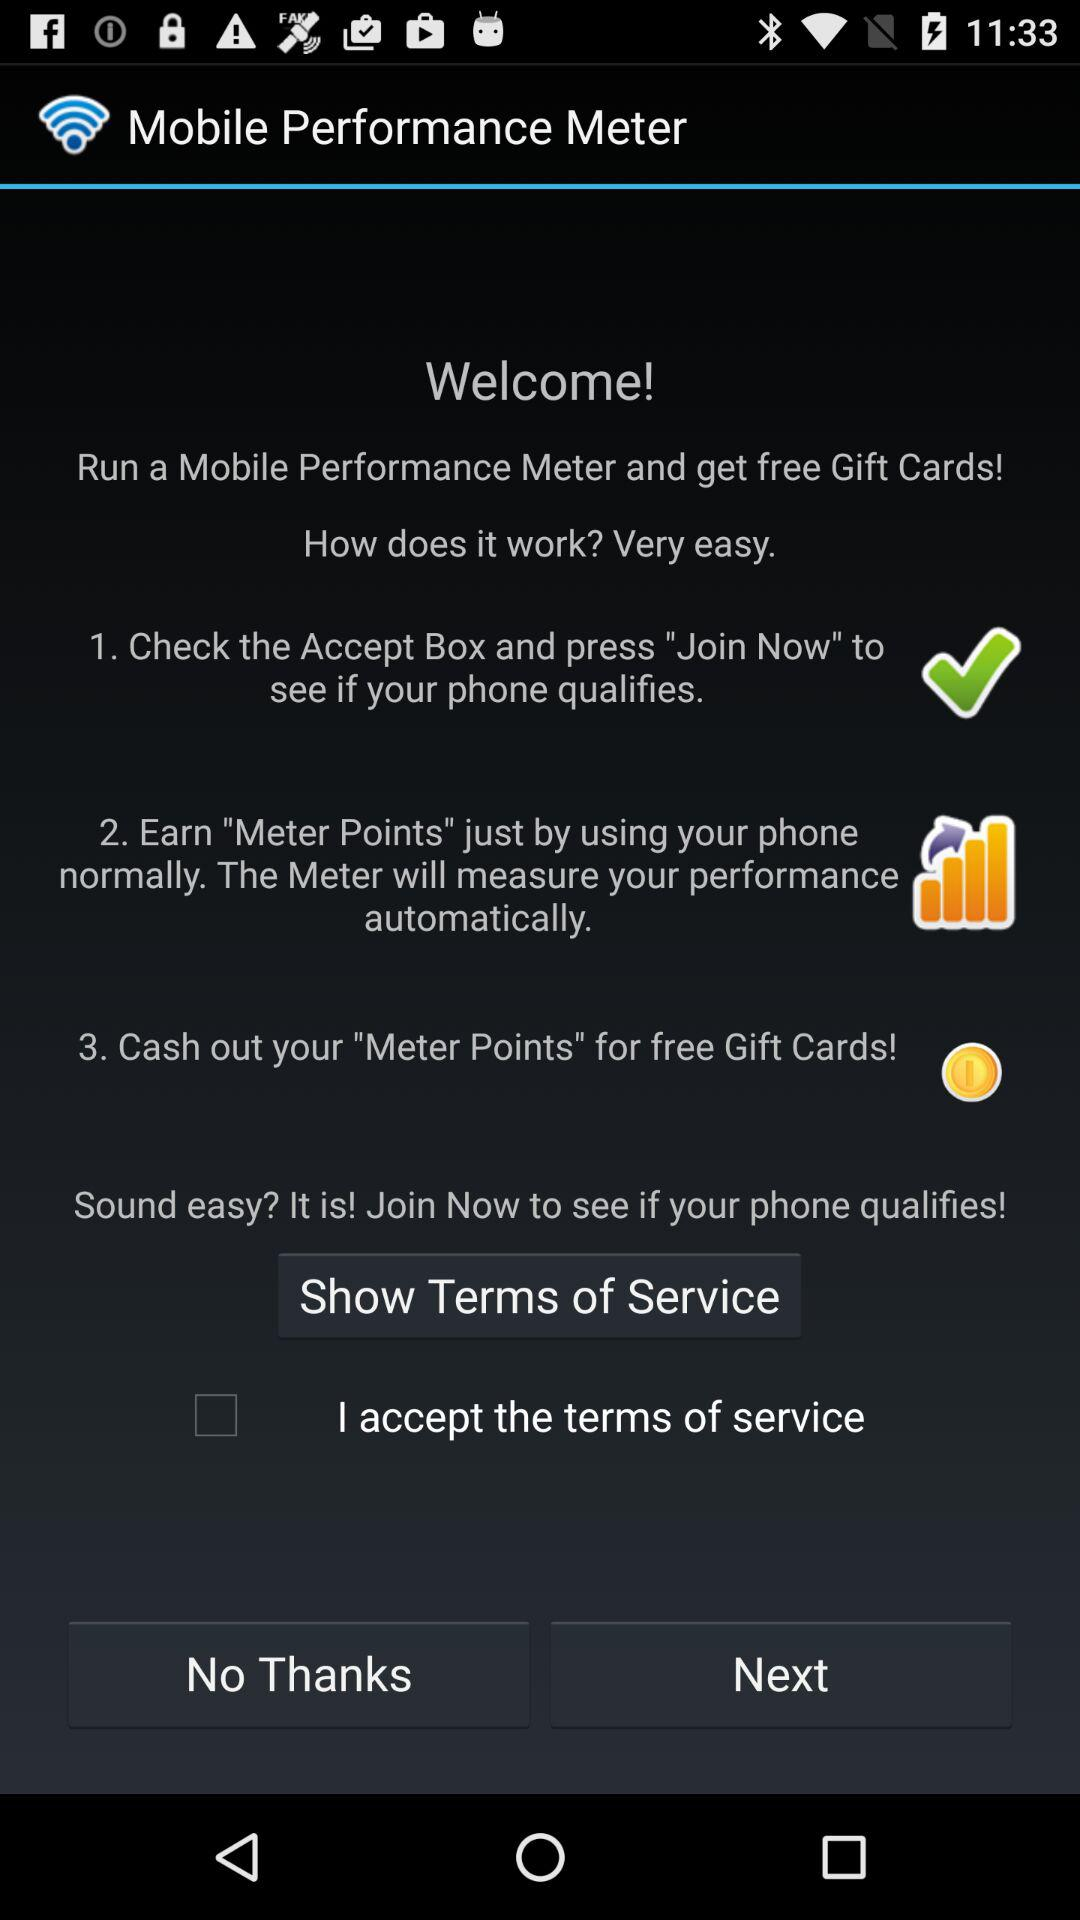How can "Meter Points" be earned? "Meter Points" can be earned by using your phone normally. 